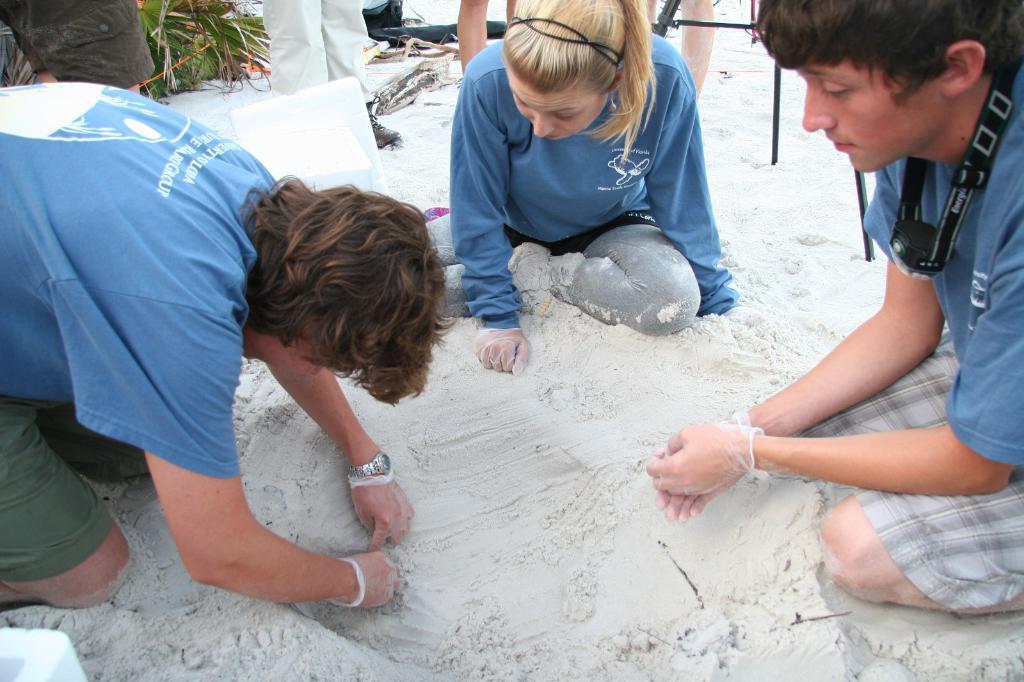Could you give a brief overview of what you see in this image? Here I can see three people are sitting on the sand and looking at the downwards. It seems like they are making sand art. Two are men and one is woman. Three are wearing blue color t-shirts and shorts. At the top I can see some more people are standing and also there is a plant. 